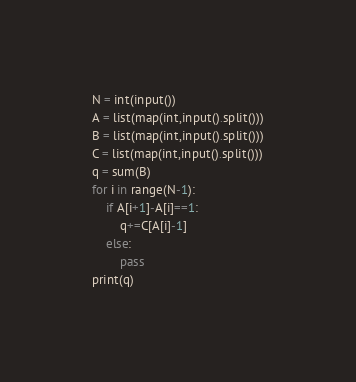Convert code to text. <code><loc_0><loc_0><loc_500><loc_500><_Python_>N = int(input())
A = list(map(int,input().split()))
B = list(map(int,input().split()))
C = list(map(int,input().split()))
q = sum(B)
for i in range(N-1):
    if A[i+1]-A[i]==1:
        q+=C[A[i]-1]
    else:
        pass
print(q)</code> 